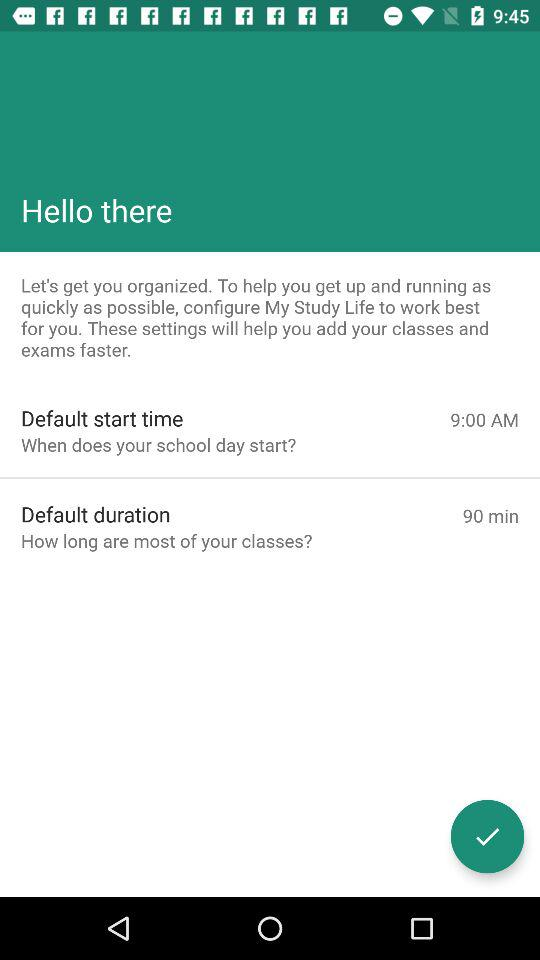What is the time duration of most of your classes? The time duration of most of your classes is 90 minutes. 